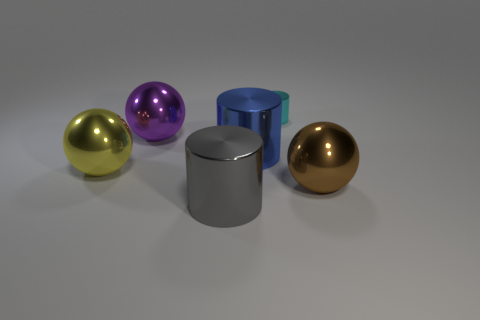Is there anything else that is the same size as the cyan cylinder?
Your response must be concise. No. What is the shape of the metallic thing that is behind the purple metal thing left of the big sphere that is on the right side of the big purple sphere?
Keep it short and to the point. Cylinder. Do the gray cylinder and the sphere behind the yellow metallic thing have the same size?
Ensure brevity in your answer.  Yes. What is the shape of the big shiny thing that is right of the purple shiny ball and behind the big brown sphere?
Provide a short and direct response. Cylinder. How many small objects are blue shiny spheres or yellow metallic spheres?
Make the answer very short. 0. Are there the same number of large gray shiny cylinders right of the large blue cylinder and cylinders that are in front of the gray thing?
Your answer should be compact. Yes. What number of other objects are there of the same color as the small cylinder?
Your answer should be very brief. 0. Are there an equal number of large brown metal things to the left of the brown object and big brown balls?
Your answer should be compact. No. Is the yellow object the same size as the gray cylinder?
Make the answer very short. Yes. There is a cylinder that is both to the left of the cyan object and behind the yellow metallic ball; what material is it made of?
Give a very brief answer. Metal. 